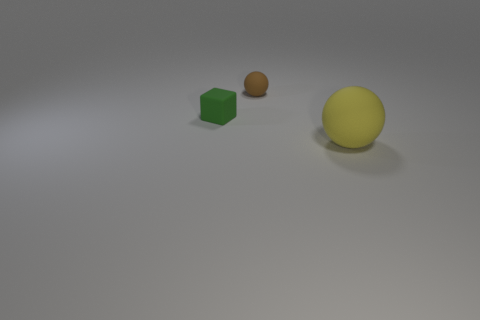Are there any other things that are the same size as the yellow sphere?
Make the answer very short. No. There is a thing on the left side of the rubber sphere that is behind the green object; how many small things are in front of it?
Your answer should be compact. 0. What is the color of the large matte thing?
Give a very brief answer. Yellow. How many other things are there of the same size as the brown object?
Make the answer very short. 1. What is the material of the tiny thing on the left side of the rubber ball left of the sphere in front of the brown thing?
Make the answer very short. Rubber. There is a yellow object that is made of the same material as the green thing; what size is it?
Your answer should be very brief. Large. Are there any other things of the same color as the tiny ball?
Offer a terse response. No. There is a sphere behind the tiny green object; what color is it?
Provide a succinct answer. Brown. There is a object behind the green rubber object; is it the same size as the small rubber block?
Provide a short and direct response. Yes. Are there fewer brown balls than red metal cylinders?
Provide a short and direct response. No. 